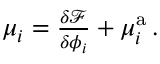Convert formula to latex. <formula><loc_0><loc_0><loc_500><loc_500>\begin{array} { r } { \mu _ { i } = \frac { \delta \mathcal { F } } { \delta \phi _ { i } } + \mu _ { i } ^ { a } \, . } \end{array}</formula> 